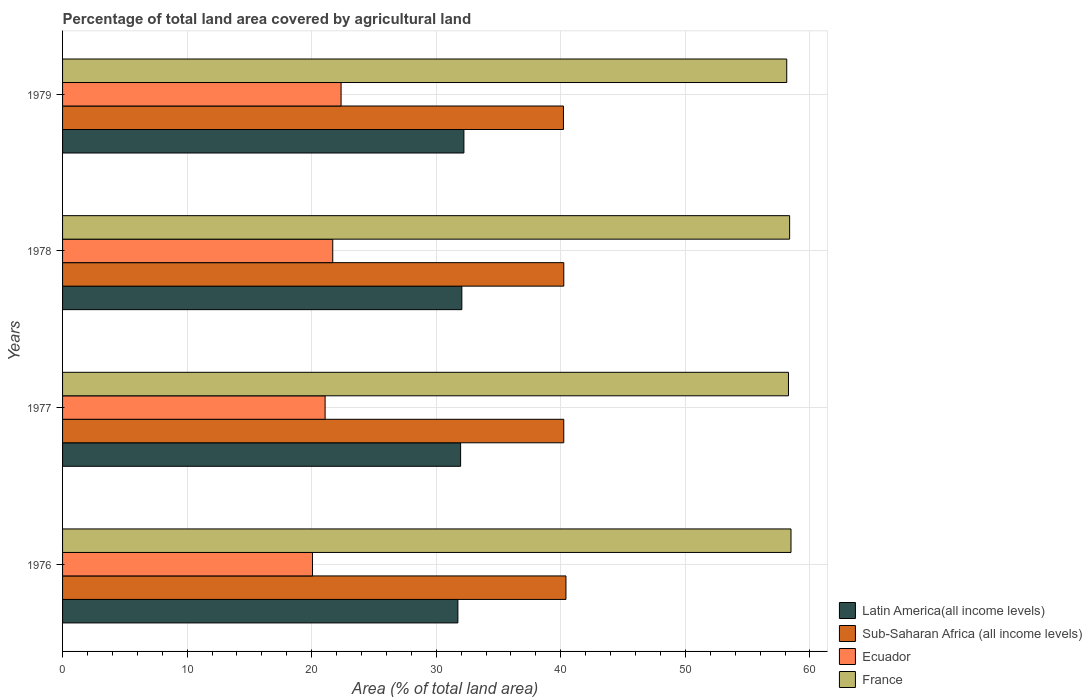How many groups of bars are there?
Give a very brief answer. 4. Are the number of bars per tick equal to the number of legend labels?
Provide a succinct answer. Yes. How many bars are there on the 1st tick from the top?
Offer a very short reply. 4. How many bars are there on the 4th tick from the bottom?
Your answer should be compact. 4. In how many cases, is the number of bars for a given year not equal to the number of legend labels?
Provide a short and direct response. 0. What is the percentage of agricultural land in Sub-Saharan Africa (all income levels) in 1976?
Your response must be concise. 40.41. Across all years, what is the maximum percentage of agricultural land in Latin America(all income levels)?
Ensure brevity in your answer.  32.22. Across all years, what is the minimum percentage of agricultural land in France?
Provide a short and direct response. 58.14. In which year was the percentage of agricultural land in Sub-Saharan Africa (all income levels) maximum?
Ensure brevity in your answer.  1976. In which year was the percentage of agricultural land in Latin America(all income levels) minimum?
Your response must be concise. 1976. What is the total percentage of agricultural land in Ecuador in the graph?
Offer a very short reply. 85.19. What is the difference between the percentage of agricultural land in Sub-Saharan Africa (all income levels) in 1977 and that in 1978?
Provide a short and direct response. -0. What is the difference between the percentage of agricultural land in Latin America(all income levels) in 1979 and the percentage of agricultural land in France in 1976?
Your answer should be very brief. -26.26. What is the average percentage of agricultural land in Sub-Saharan Africa (all income levels) per year?
Provide a succinct answer. 40.27. In the year 1978, what is the difference between the percentage of agricultural land in France and percentage of agricultural land in Ecuador?
Provide a succinct answer. 36.68. What is the ratio of the percentage of agricultural land in France in 1976 to that in 1979?
Provide a succinct answer. 1.01. Is the percentage of agricultural land in Sub-Saharan Africa (all income levels) in 1976 less than that in 1978?
Give a very brief answer. No. What is the difference between the highest and the second highest percentage of agricultural land in Ecuador?
Offer a very short reply. 0.67. What is the difference between the highest and the lowest percentage of agricultural land in Sub-Saharan Africa (all income levels)?
Offer a terse response. 0.2. What does the 1st bar from the top in 1977 represents?
Give a very brief answer. France. What does the 4th bar from the bottom in 1979 represents?
Ensure brevity in your answer.  France. Is it the case that in every year, the sum of the percentage of agricultural land in Sub-Saharan Africa (all income levels) and percentage of agricultural land in Latin America(all income levels) is greater than the percentage of agricultural land in France?
Offer a terse response. Yes. How many years are there in the graph?
Keep it short and to the point. 4. What is the difference between two consecutive major ticks on the X-axis?
Provide a succinct answer. 10. Are the values on the major ticks of X-axis written in scientific E-notation?
Your answer should be compact. No. Does the graph contain any zero values?
Ensure brevity in your answer.  No. Does the graph contain grids?
Offer a terse response. Yes. How are the legend labels stacked?
Your answer should be compact. Vertical. What is the title of the graph?
Offer a terse response. Percentage of total land area covered by agricultural land. Does "Israel" appear as one of the legend labels in the graph?
Ensure brevity in your answer.  No. What is the label or title of the X-axis?
Provide a succinct answer. Area (% of total land area). What is the label or title of the Y-axis?
Give a very brief answer. Years. What is the Area (% of total land area) in Latin America(all income levels) in 1976?
Offer a terse response. 31.74. What is the Area (% of total land area) in Sub-Saharan Africa (all income levels) in 1976?
Ensure brevity in your answer.  40.41. What is the Area (% of total land area) in Ecuador in 1976?
Provide a succinct answer. 20.07. What is the Area (% of total land area) of France in 1976?
Ensure brevity in your answer.  58.48. What is the Area (% of total land area) in Latin America(all income levels) in 1977?
Your response must be concise. 31.96. What is the Area (% of total land area) in Sub-Saharan Africa (all income levels) in 1977?
Give a very brief answer. 40.24. What is the Area (% of total land area) of Ecuador in 1977?
Keep it short and to the point. 21.08. What is the Area (% of total land area) of France in 1977?
Offer a terse response. 58.28. What is the Area (% of total land area) of Latin America(all income levels) in 1978?
Provide a short and direct response. 32.05. What is the Area (% of total land area) of Sub-Saharan Africa (all income levels) in 1978?
Your answer should be very brief. 40.24. What is the Area (% of total land area) of Ecuador in 1978?
Offer a very short reply. 21.69. What is the Area (% of total land area) in France in 1978?
Offer a terse response. 58.37. What is the Area (% of total land area) of Latin America(all income levels) in 1979?
Your answer should be compact. 32.22. What is the Area (% of total land area) in Sub-Saharan Africa (all income levels) in 1979?
Offer a very short reply. 40.21. What is the Area (% of total land area) of Ecuador in 1979?
Your response must be concise. 22.36. What is the Area (% of total land area) of France in 1979?
Make the answer very short. 58.14. Across all years, what is the maximum Area (% of total land area) of Latin America(all income levels)?
Keep it short and to the point. 32.22. Across all years, what is the maximum Area (% of total land area) in Sub-Saharan Africa (all income levels)?
Your answer should be compact. 40.41. Across all years, what is the maximum Area (% of total land area) in Ecuador?
Keep it short and to the point. 22.36. Across all years, what is the maximum Area (% of total land area) in France?
Offer a very short reply. 58.48. Across all years, what is the minimum Area (% of total land area) in Latin America(all income levels)?
Your answer should be very brief. 31.74. Across all years, what is the minimum Area (% of total land area) of Sub-Saharan Africa (all income levels)?
Provide a succinct answer. 40.21. Across all years, what is the minimum Area (% of total land area) in Ecuador?
Your response must be concise. 20.07. Across all years, what is the minimum Area (% of total land area) of France?
Provide a short and direct response. 58.14. What is the total Area (% of total land area) in Latin America(all income levels) in the graph?
Give a very brief answer. 127.97. What is the total Area (% of total land area) in Sub-Saharan Africa (all income levels) in the graph?
Ensure brevity in your answer.  161.1. What is the total Area (% of total land area) in Ecuador in the graph?
Keep it short and to the point. 85.19. What is the total Area (% of total land area) in France in the graph?
Provide a succinct answer. 233.26. What is the difference between the Area (% of total land area) of Latin America(all income levels) in 1976 and that in 1977?
Offer a terse response. -0.22. What is the difference between the Area (% of total land area) in Sub-Saharan Africa (all income levels) in 1976 and that in 1977?
Offer a very short reply. 0.18. What is the difference between the Area (% of total land area) of Ecuador in 1976 and that in 1977?
Your response must be concise. -1.01. What is the difference between the Area (% of total land area) in France in 1976 and that in 1977?
Ensure brevity in your answer.  0.2. What is the difference between the Area (% of total land area) in Latin America(all income levels) in 1976 and that in 1978?
Offer a very short reply. -0.32. What is the difference between the Area (% of total land area) in Sub-Saharan Africa (all income levels) in 1976 and that in 1978?
Offer a very short reply. 0.17. What is the difference between the Area (% of total land area) of Ecuador in 1976 and that in 1978?
Keep it short and to the point. -1.63. What is the difference between the Area (% of total land area) in France in 1976 and that in 1978?
Make the answer very short. 0.11. What is the difference between the Area (% of total land area) in Latin America(all income levels) in 1976 and that in 1979?
Offer a terse response. -0.48. What is the difference between the Area (% of total land area) in Sub-Saharan Africa (all income levels) in 1976 and that in 1979?
Your response must be concise. 0.2. What is the difference between the Area (% of total land area) of Ecuador in 1976 and that in 1979?
Offer a terse response. -2.29. What is the difference between the Area (% of total land area) in France in 1976 and that in 1979?
Offer a terse response. 0.34. What is the difference between the Area (% of total land area) of Latin America(all income levels) in 1977 and that in 1978?
Ensure brevity in your answer.  -0.1. What is the difference between the Area (% of total land area) in Sub-Saharan Africa (all income levels) in 1977 and that in 1978?
Your answer should be very brief. -0. What is the difference between the Area (% of total land area) of Ecuador in 1977 and that in 1978?
Offer a terse response. -0.61. What is the difference between the Area (% of total land area) of France in 1977 and that in 1978?
Make the answer very short. -0.09. What is the difference between the Area (% of total land area) in Latin America(all income levels) in 1977 and that in 1979?
Provide a succinct answer. -0.26. What is the difference between the Area (% of total land area) in Sub-Saharan Africa (all income levels) in 1977 and that in 1979?
Your answer should be compact. 0.02. What is the difference between the Area (% of total land area) of Ecuador in 1977 and that in 1979?
Keep it short and to the point. -1.28. What is the difference between the Area (% of total land area) of France in 1977 and that in 1979?
Provide a short and direct response. 0.14. What is the difference between the Area (% of total land area) of Latin America(all income levels) in 1978 and that in 1979?
Your answer should be very brief. -0.17. What is the difference between the Area (% of total land area) of Sub-Saharan Africa (all income levels) in 1978 and that in 1979?
Provide a short and direct response. 0.03. What is the difference between the Area (% of total land area) of Ecuador in 1978 and that in 1979?
Your answer should be very brief. -0.67. What is the difference between the Area (% of total land area) in France in 1978 and that in 1979?
Your answer should be compact. 0.23. What is the difference between the Area (% of total land area) of Latin America(all income levels) in 1976 and the Area (% of total land area) of Sub-Saharan Africa (all income levels) in 1977?
Provide a short and direct response. -8.5. What is the difference between the Area (% of total land area) of Latin America(all income levels) in 1976 and the Area (% of total land area) of Ecuador in 1977?
Ensure brevity in your answer.  10.66. What is the difference between the Area (% of total land area) of Latin America(all income levels) in 1976 and the Area (% of total land area) of France in 1977?
Provide a succinct answer. -26.54. What is the difference between the Area (% of total land area) in Sub-Saharan Africa (all income levels) in 1976 and the Area (% of total land area) in Ecuador in 1977?
Keep it short and to the point. 19.33. What is the difference between the Area (% of total land area) in Sub-Saharan Africa (all income levels) in 1976 and the Area (% of total land area) in France in 1977?
Offer a terse response. -17.86. What is the difference between the Area (% of total land area) in Ecuador in 1976 and the Area (% of total land area) in France in 1977?
Make the answer very short. -38.21. What is the difference between the Area (% of total land area) of Latin America(all income levels) in 1976 and the Area (% of total land area) of Sub-Saharan Africa (all income levels) in 1978?
Make the answer very short. -8.5. What is the difference between the Area (% of total land area) of Latin America(all income levels) in 1976 and the Area (% of total land area) of Ecuador in 1978?
Your response must be concise. 10.05. What is the difference between the Area (% of total land area) in Latin America(all income levels) in 1976 and the Area (% of total land area) in France in 1978?
Your answer should be compact. -26.63. What is the difference between the Area (% of total land area) of Sub-Saharan Africa (all income levels) in 1976 and the Area (% of total land area) of Ecuador in 1978?
Your answer should be very brief. 18.72. What is the difference between the Area (% of total land area) of Sub-Saharan Africa (all income levels) in 1976 and the Area (% of total land area) of France in 1978?
Your answer should be compact. -17.96. What is the difference between the Area (% of total land area) of Ecuador in 1976 and the Area (% of total land area) of France in 1978?
Your answer should be compact. -38.3. What is the difference between the Area (% of total land area) in Latin America(all income levels) in 1976 and the Area (% of total land area) in Sub-Saharan Africa (all income levels) in 1979?
Your response must be concise. -8.47. What is the difference between the Area (% of total land area) of Latin America(all income levels) in 1976 and the Area (% of total land area) of Ecuador in 1979?
Offer a very short reply. 9.38. What is the difference between the Area (% of total land area) in Latin America(all income levels) in 1976 and the Area (% of total land area) in France in 1979?
Make the answer very short. -26.4. What is the difference between the Area (% of total land area) in Sub-Saharan Africa (all income levels) in 1976 and the Area (% of total land area) in Ecuador in 1979?
Your response must be concise. 18.05. What is the difference between the Area (% of total land area) in Sub-Saharan Africa (all income levels) in 1976 and the Area (% of total land area) in France in 1979?
Offer a terse response. -17.73. What is the difference between the Area (% of total land area) in Ecuador in 1976 and the Area (% of total land area) in France in 1979?
Provide a short and direct response. -38.07. What is the difference between the Area (% of total land area) of Latin America(all income levels) in 1977 and the Area (% of total land area) of Sub-Saharan Africa (all income levels) in 1978?
Your answer should be compact. -8.28. What is the difference between the Area (% of total land area) of Latin America(all income levels) in 1977 and the Area (% of total land area) of Ecuador in 1978?
Provide a short and direct response. 10.26. What is the difference between the Area (% of total land area) in Latin America(all income levels) in 1977 and the Area (% of total land area) in France in 1978?
Give a very brief answer. -26.41. What is the difference between the Area (% of total land area) of Sub-Saharan Africa (all income levels) in 1977 and the Area (% of total land area) of Ecuador in 1978?
Your response must be concise. 18.55. What is the difference between the Area (% of total land area) of Sub-Saharan Africa (all income levels) in 1977 and the Area (% of total land area) of France in 1978?
Make the answer very short. -18.13. What is the difference between the Area (% of total land area) in Ecuador in 1977 and the Area (% of total land area) in France in 1978?
Ensure brevity in your answer.  -37.29. What is the difference between the Area (% of total land area) of Latin America(all income levels) in 1977 and the Area (% of total land area) of Sub-Saharan Africa (all income levels) in 1979?
Provide a short and direct response. -8.26. What is the difference between the Area (% of total land area) in Latin America(all income levels) in 1977 and the Area (% of total land area) in Ecuador in 1979?
Give a very brief answer. 9.6. What is the difference between the Area (% of total land area) in Latin America(all income levels) in 1977 and the Area (% of total land area) in France in 1979?
Keep it short and to the point. -26.18. What is the difference between the Area (% of total land area) in Sub-Saharan Africa (all income levels) in 1977 and the Area (% of total land area) in Ecuador in 1979?
Offer a very short reply. 17.88. What is the difference between the Area (% of total land area) of Sub-Saharan Africa (all income levels) in 1977 and the Area (% of total land area) of France in 1979?
Provide a succinct answer. -17.9. What is the difference between the Area (% of total land area) of Ecuador in 1977 and the Area (% of total land area) of France in 1979?
Provide a short and direct response. -37.06. What is the difference between the Area (% of total land area) of Latin America(all income levels) in 1978 and the Area (% of total land area) of Sub-Saharan Africa (all income levels) in 1979?
Give a very brief answer. -8.16. What is the difference between the Area (% of total land area) of Latin America(all income levels) in 1978 and the Area (% of total land area) of Ecuador in 1979?
Provide a succinct answer. 9.7. What is the difference between the Area (% of total land area) in Latin America(all income levels) in 1978 and the Area (% of total land area) in France in 1979?
Your response must be concise. -26.08. What is the difference between the Area (% of total land area) of Sub-Saharan Africa (all income levels) in 1978 and the Area (% of total land area) of Ecuador in 1979?
Your answer should be compact. 17.88. What is the difference between the Area (% of total land area) of Sub-Saharan Africa (all income levels) in 1978 and the Area (% of total land area) of France in 1979?
Make the answer very short. -17.9. What is the difference between the Area (% of total land area) in Ecuador in 1978 and the Area (% of total land area) in France in 1979?
Ensure brevity in your answer.  -36.45. What is the average Area (% of total land area) in Latin America(all income levels) per year?
Provide a short and direct response. 31.99. What is the average Area (% of total land area) in Sub-Saharan Africa (all income levels) per year?
Make the answer very short. 40.27. What is the average Area (% of total land area) of Ecuador per year?
Ensure brevity in your answer.  21.3. What is the average Area (% of total land area) of France per year?
Give a very brief answer. 58.32. In the year 1976, what is the difference between the Area (% of total land area) of Latin America(all income levels) and Area (% of total land area) of Sub-Saharan Africa (all income levels)?
Ensure brevity in your answer.  -8.67. In the year 1976, what is the difference between the Area (% of total land area) of Latin America(all income levels) and Area (% of total land area) of Ecuador?
Offer a very short reply. 11.67. In the year 1976, what is the difference between the Area (% of total land area) in Latin America(all income levels) and Area (% of total land area) in France?
Make the answer very short. -26.74. In the year 1976, what is the difference between the Area (% of total land area) in Sub-Saharan Africa (all income levels) and Area (% of total land area) in Ecuador?
Provide a short and direct response. 20.35. In the year 1976, what is the difference between the Area (% of total land area) of Sub-Saharan Africa (all income levels) and Area (% of total land area) of France?
Provide a short and direct response. -18.07. In the year 1976, what is the difference between the Area (% of total land area) of Ecuador and Area (% of total land area) of France?
Keep it short and to the point. -38.41. In the year 1977, what is the difference between the Area (% of total land area) in Latin America(all income levels) and Area (% of total land area) in Sub-Saharan Africa (all income levels)?
Offer a very short reply. -8.28. In the year 1977, what is the difference between the Area (% of total land area) of Latin America(all income levels) and Area (% of total land area) of Ecuador?
Your answer should be very brief. 10.88. In the year 1977, what is the difference between the Area (% of total land area) of Latin America(all income levels) and Area (% of total land area) of France?
Make the answer very short. -26.32. In the year 1977, what is the difference between the Area (% of total land area) in Sub-Saharan Africa (all income levels) and Area (% of total land area) in Ecuador?
Your answer should be compact. 19.16. In the year 1977, what is the difference between the Area (% of total land area) in Sub-Saharan Africa (all income levels) and Area (% of total land area) in France?
Offer a very short reply. -18.04. In the year 1977, what is the difference between the Area (% of total land area) in Ecuador and Area (% of total land area) in France?
Your response must be concise. -37.2. In the year 1978, what is the difference between the Area (% of total land area) in Latin America(all income levels) and Area (% of total land area) in Sub-Saharan Africa (all income levels)?
Offer a terse response. -8.18. In the year 1978, what is the difference between the Area (% of total land area) of Latin America(all income levels) and Area (% of total land area) of Ecuador?
Give a very brief answer. 10.36. In the year 1978, what is the difference between the Area (% of total land area) in Latin America(all income levels) and Area (% of total land area) in France?
Provide a short and direct response. -26.31. In the year 1978, what is the difference between the Area (% of total land area) of Sub-Saharan Africa (all income levels) and Area (% of total land area) of Ecuador?
Your answer should be compact. 18.55. In the year 1978, what is the difference between the Area (% of total land area) in Sub-Saharan Africa (all income levels) and Area (% of total land area) in France?
Your answer should be very brief. -18.13. In the year 1978, what is the difference between the Area (% of total land area) in Ecuador and Area (% of total land area) in France?
Your response must be concise. -36.68. In the year 1979, what is the difference between the Area (% of total land area) in Latin America(all income levels) and Area (% of total land area) in Sub-Saharan Africa (all income levels)?
Your response must be concise. -7.99. In the year 1979, what is the difference between the Area (% of total land area) of Latin America(all income levels) and Area (% of total land area) of Ecuador?
Make the answer very short. 9.86. In the year 1979, what is the difference between the Area (% of total land area) in Latin America(all income levels) and Area (% of total land area) in France?
Give a very brief answer. -25.92. In the year 1979, what is the difference between the Area (% of total land area) of Sub-Saharan Africa (all income levels) and Area (% of total land area) of Ecuador?
Keep it short and to the point. 17.85. In the year 1979, what is the difference between the Area (% of total land area) of Sub-Saharan Africa (all income levels) and Area (% of total land area) of France?
Provide a succinct answer. -17.93. In the year 1979, what is the difference between the Area (% of total land area) of Ecuador and Area (% of total land area) of France?
Offer a very short reply. -35.78. What is the ratio of the Area (% of total land area) of Latin America(all income levels) in 1976 to that in 1977?
Provide a succinct answer. 0.99. What is the ratio of the Area (% of total land area) in Sub-Saharan Africa (all income levels) in 1976 to that in 1977?
Make the answer very short. 1. What is the ratio of the Area (% of total land area) of Sub-Saharan Africa (all income levels) in 1976 to that in 1978?
Offer a very short reply. 1. What is the ratio of the Area (% of total land area) of Ecuador in 1976 to that in 1978?
Give a very brief answer. 0.93. What is the ratio of the Area (% of total land area) of Latin America(all income levels) in 1976 to that in 1979?
Give a very brief answer. 0.98. What is the ratio of the Area (% of total land area) of Sub-Saharan Africa (all income levels) in 1976 to that in 1979?
Offer a terse response. 1. What is the ratio of the Area (% of total land area) in Ecuador in 1976 to that in 1979?
Your answer should be very brief. 0.9. What is the ratio of the Area (% of total land area) of France in 1976 to that in 1979?
Offer a very short reply. 1.01. What is the ratio of the Area (% of total land area) of Latin America(all income levels) in 1977 to that in 1978?
Keep it short and to the point. 1. What is the ratio of the Area (% of total land area) of Sub-Saharan Africa (all income levels) in 1977 to that in 1978?
Your answer should be very brief. 1. What is the ratio of the Area (% of total land area) of Ecuador in 1977 to that in 1978?
Keep it short and to the point. 0.97. What is the ratio of the Area (% of total land area) in Ecuador in 1977 to that in 1979?
Make the answer very short. 0.94. What is the ratio of the Area (% of total land area) of France in 1977 to that in 1979?
Provide a succinct answer. 1. What is the ratio of the Area (% of total land area) in Ecuador in 1978 to that in 1979?
Make the answer very short. 0.97. What is the ratio of the Area (% of total land area) of France in 1978 to that in 1979?
Your response must be concise. 1. What is the difference between the highest and the second highest Area (% of total land area) of Latin America(all income levels)?
Your answer should be very brief. 0.17. What is the difference between the highest and the second highest Area (% of total land area) in Sub-Saharan Africa (all income levels)?
Ensure brevity in your answer.  0.17. What is the difference between the highest and the second highest Area (% of total land area) of Ecuador?
Offer a terse response. 0.67. What is the difference between the highest and the second highest Area (% of total land area) of France?
Provide a short and direct response. 0.11. What is the difference between the highest and the lowest Area (% of total land area) in Latin America(all income levels)?
Provide a short and direct response. 0.48. What is the difference between the highest and the lowest Area (% of total land area) of Sub-Saharan Africa (all income levels)?
Your response must be concise. 0.2. What is the difference between the highest and the lowest Area (% of total land area) in Ecuador?
Keep it short and to the point. 2.29. What is the difference between the highest and the lowest Area (% of total land area) in France?
Provide a succinct answer. 0.34. 